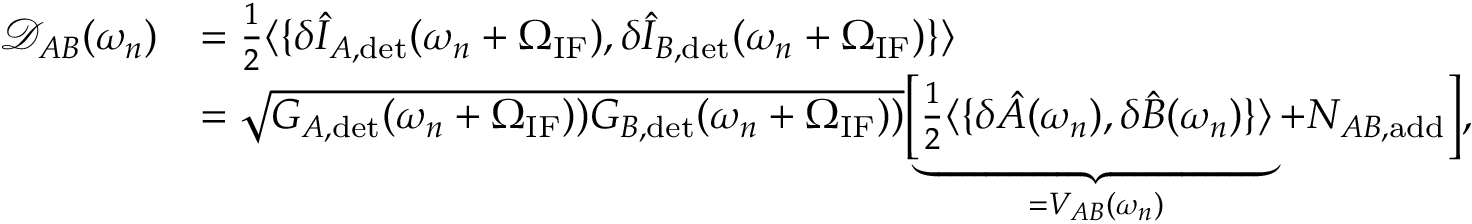<formula> <loc_0><loc_0><loc_500><loc_500>\begin{array} { r l } { \mathcal { D } _ { A B } ( \omega _ { n } ) } & { = \frac { 1 } { 2 } \langle \{ \delta \hat { I } _ { A , d e t } ( \omega _ { n } + \Omega _ { I F } ) , \delta \hat { I } _ { B , d e t } ( \omega _ { n } + \Omega _ { I F } ) \} \rangle } \\ & { = \sqrt { G _ { A , d e t } ( \omega _ { n } + \Omega _ { I F } ) ) G _ { B , d e t } ( \omega _ { n } + \Omega _ { I F } ) ) } \left [ \underbrace { \frac { 1 } { 2 } \langle \{ \delta \hat { A } ( \omega _ { n } ) , \delta \hat { B } ( \omega _ { n } ) \} \rangle } _ { = V _ { A B } ( \omega _ { n } ) } + N _ { A B , a d d } \right ] , } \end{array}</formula> 